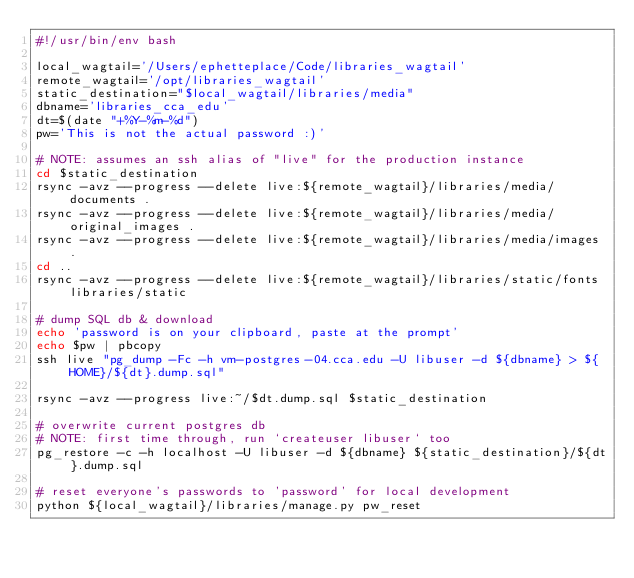<code> <loc_0><loc_0><loc_500><loc_500><_Bash_>#!/usr/bin/env bash

local_wagtail='/Users/ephetteplace/Code/libraries_wagtail'
remote_wagtail='/opt/libraries_wagtail'
static_destination="$local_wagtail/libraries/media"
dbname='libraries_cca_edu'
dt=$(date "+%Y-%m-%d")
pw='This is not the actual password :)'

# NOTE: assumes an ssh alias of "live" for the production instance
cd $static_destination
rsync -avz --progress --delete live:${remote_wagtail}/libraries/media/documents .
rsync -avz --progress --delete live:${remote_wagtail}/libraries/media/original_images .
rsync -avz --progress --delete live:${remote_wagtail}/libraries/media/images .
cd ..
rsync -avz --progress --delete live:${remote_wagtail}/libraries/static/fonts libraries/static

# dump SQL db & download
echo 'password is on your clipboard, paste at the prompt'
echo $pw | pbcopy
ssh live "pg_dump -Fc -h vm-postgres-04.cca.edu -U libuser -d ${dbname} > ${HOME}/${dt}.dump.sql"

rsync -avz --progress live:~/$dt.dump.sql $static_destination

# overwrite current postgres db
# NOTE: first time through, run `createuser libuser` too
pg_restore -c -h localhost -U libuser -d ${dbname} ${static_destination}/${dt}.dump.sql

# reset everyone's passwords to 'password' for local development
python ${local_wagtail}/libraries/manage.py pw_reset
</code> 